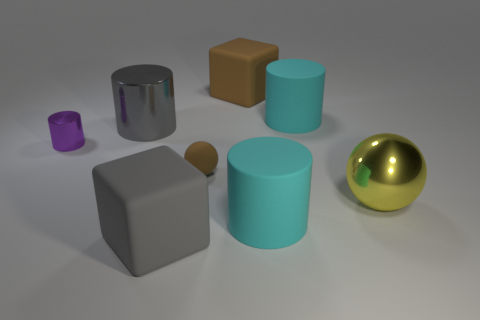Add 2 tiny purple metallic cylinders. How many objects exist? 10 Subtract all balls. How many objects are left? 6 Subtract all big rubber cylinders. Subtract all tiny purple things. How many objects are left? 5 Add 5 rubber balls. How many rubber balls are left? 6 Add 1 small brown metallic spheres. How many small brown metallic spheres exist? 1 Subtract 1 gray cylinders. How many objects are left? 7 